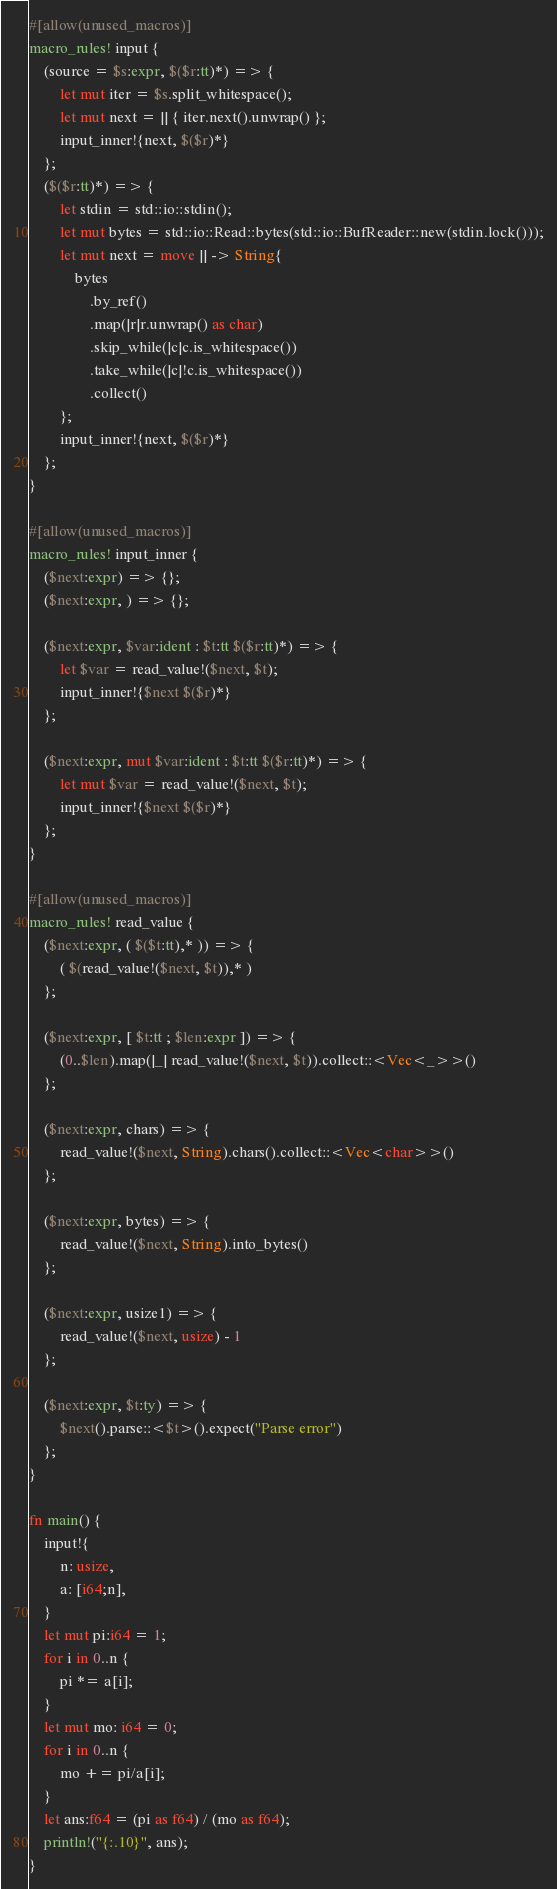Convert code to text. <code><loc_0><loc_0><loc_500><loc_500><_Rust_>#[allow(unused_macros)]
macro_rules! input {
    (source = $s:expr, $($r:tt)*) => {
        let mut iter = $s.split_whitespace();
        let mut next = || { iter.next().unwrap() };
        input_inner!{next, $($r)*}
    };
    ($($r:tt)*) => {
        let stdin = std::io::stdin();
        let mut bytes = std::io::Read::bytes(std::io::BufReader::new(stdin.lock()));
        let mut next = move || -> String{
            bytes
                .by_ref()
                .map(|r|r.unwrap() as char)
                .skip_while(|c|c.is_whitespace())
                .take_while(|c|!c.is_whitespace())
                .collect()
        };
        input_inner!{next, $($r)*}
    };
}

#[allow(unused_macros)]
macro_rules! input_inner {
    ($next:expr) => {};
    ($next:expr, ) => {};

    ($next:expr, $var:ident : $t:tt $($r:tt)*) => {
        let $var = read_value!($next, $t);
        input_inner!{$next $($r)*}
    };

    ($next:expr, mut $var:ident : $t:tt $($r:tt)*) => {
        let mut $var = read_value!($next, $t);
        input_inner!{$next $($r)*}
    };
}

#[allow(unused_macros)]
macro_rules! read_value {
    ($next:expr, ( $($t:tt),* )) => {
        ( $(read_value!($next, $t)),* )
    };

    ($next:expr, [ $t:tt ; $len:expr ]) => {
        (0..$len).map(|_| read_value!($next, $t)).collect::<Vec<_>>()
    };

    ($next:expr, chars) => {
        read_value!($next, String).chars().collect::<Vec<char>>()
    };

    ($next:expr, bytes) => {
        read_value!($next, String).into_bytes()
    };

    ($next:expr, usize1) => {
        read_value!($next, usize) - 1
    };

    ($next:expr, $t:ty) => {
        $next().parse::<$t>().expect("Parse error")
    };
}

fn main() {
    input!{
        n: usize,
        a: [i64;n],
    }
    let mut pi:i64 = 1;
    for i in 0..n {
        pi *= a[i];
    }
    let mut mo: i64 = 0;
    for i in 0..n {
        mo += pi/a[i];
    }
    let ans:f64 = (pi as f64) / (mo as f64);
    println!("{:.10}", ans);
}</code> 